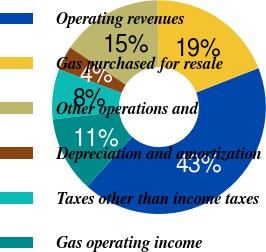Convert chart to OTSL. <chart><loc_0><loc_0><loc_500><loc_500><pie_chart><fcel>Operating revenues<fcel>Gas purchased for resale<fcel>Other operations and<fcel>Depreciation and amortization<fcel>Taxes other than income taxes<fcel>Gas operating income<nl><fcel>42.65%<fcel>19.26%<fcel>15.37%<fcel>3.68%<fcel>7.57%<fcel>11.47%<nl></chart> 